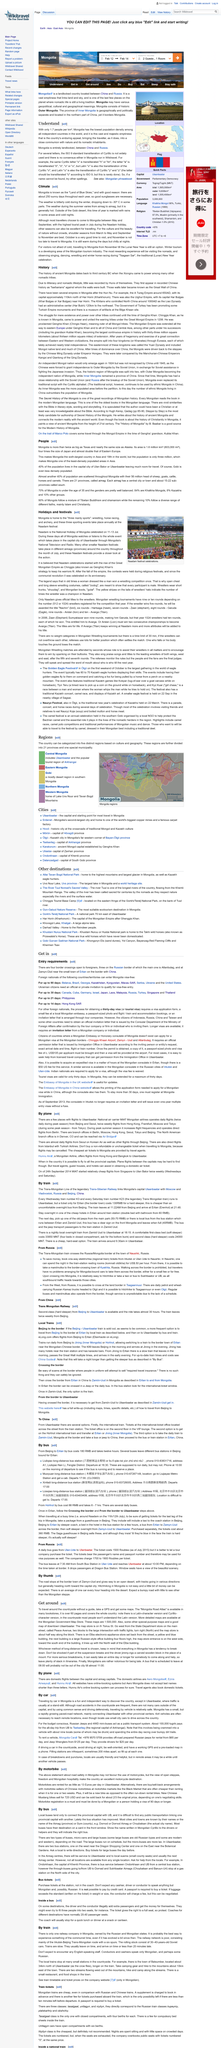Specify some key components in this picture. The Mongolia Road Atlas is over 60 pages long and provides comprehensive information on the road network in Mongolia. Yes, GPS and maps are necessary to navigate without a guide. The Mongolia Road Atlas is available in many bookstores and can be accessed by the general public for their convenience and ease of navigation. 